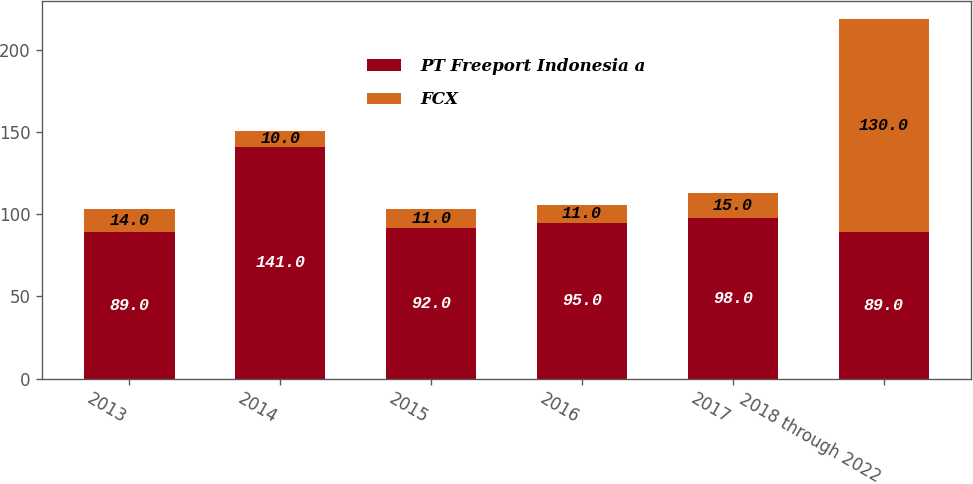<chart> <loc_0><loc_0><loc_500><loc_500><stacked_bar_chart><ecel><fcel>2013<fcel>2014<fcel>2015<fcel>2016<fcel>2017<fcel>2018 through 2022<nl><fcel>PT Freeport Indonesia a<fcel>89<fcel>141<fcel>92<fcel>95<fcel>98<fcel>89<nl><fcel>FCX<fcel>14<fcel>10<fcel>11<fcel>11<fcel>15<fcel>130<nl></chart> 